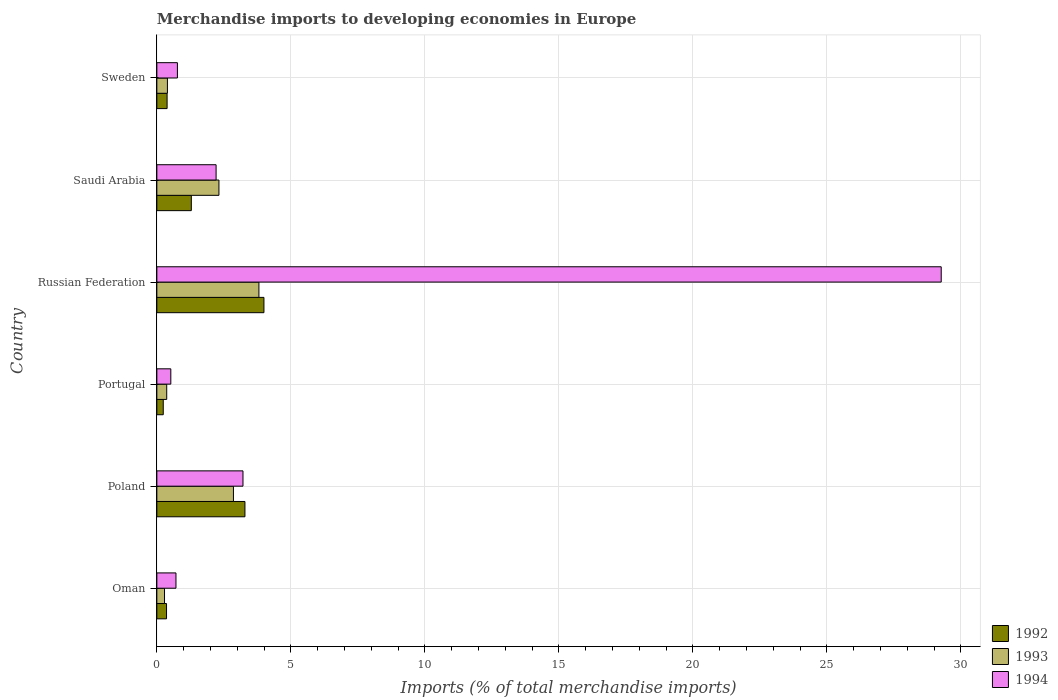How many different coloured bars are there?
Your response must be concise. 3. Are the number of bars per tick equal to the number of legend labels?
Provide a short and direct response. Yes. What is the label of the 2nd group of bars from the top?
Offer a terse response. Saudi Arabia. In how many cases, is the number of bars for a given country not equal to the number of legend labels?
Provide a short and direct response. 0. What is the percentage total merchandise imports in 1994 in Oman?
Offer a terse response. 0.71. Across all countries, what is the maximum percentage total merchandise imports in 1994?
Ensure brevity in your answer.  29.26. Across all countries, what is the minimum percentage total merchandise imports in 1992?
Provide a succinct answer. 0.24. In which country was the percentage total merchandise imports in 1992 maximum?
Your response must be concise. Russian Federation. What is the total percentage total merchandise imports in 1994 in the graph?
Your answer should be compact. 36.69. What is the difference between the percentage total merchandise imports in 1993 in Oman and that in Portugal?
Ensure brevity in your answer.  -0.08. What is the difference between the percentage total merchandise imports in 1993 in Saudi Arabia and the percentage total merchandise imports in 1994 in Sweden?
Your response must be concise. 1.55. What is the average percentage total merchandise imports in 1992 per country?
Give a very brief answer. 1.59. What is the difference between the percentage total merchandise imports in 1994 and percentage total merchandise imports in 1993 in Portugal?
Give a very brief answer. 0.15. What is the ratio of the percentage total merchandise imports in 1993 in Portugal to that in Saudi Arabia?
Offer a very short reply. 0.16. Is the percentage total merchandise imports in 1993 in Poland less than that in Portugal?
Make the answer very short. No. What is the difference between the highest and the second highest percentage total merchandise imports in 1994?
Ensure brevity in your answer.  26.05. What is the difference between the highest and the lowest percentage total merchandise imports in 1994?
Ensure brevity in your answer.  28.74. What does the 1st bar from the bottom in Oman represents?
Make the answer very short. 1992. Is it the case that in every country, the sum of the percentage total merchandise imports in 1992 and percentage total merchandise imports in 1994 is greater than the percentage total merchandise imports in 1993?
Ensure brevity in your answer.  Yes. Are all the bars in the graph horizontal?
Your answer should be very brief. Yes. How many countries are there in the graph?
Your response must be concise. 6. Does the graph contain any zero values?
Your response must be concise. No. Where does the legend appear in the graph?
Provide a short and direct response. Bottom right. How many legend labels are there?
Your answer should be very brief. 3. What is the title of the graph?
Provide a succinct answer. Merchandise imports to developing economies in Europe. Does "1960" appear as one of the legend labels in the graph?
Your response must be concise. No. What is the label or title of the X-axis?
Your answer should be compact. Imports (% of total merchandise imports). What is the label or title of the Y-axis?
Your answer should be very brief. Country. What is the Imports (% of total merchandise imports) in 1992 in Oman?
Ensure brevity in your answer.  0.36. What is the Imports (% of total merchandise imports) in 1993 in Oman?
Give a very brief answer. 0.29. What is the Imports (% of total merchandise imports) in 1994 in Oman?
Make the answer very short. 0.71. What is the Imports (% of total merchandise imports) of 1992 in Poland?
Offer a very short reply. 3.29. What is the Imports (% of total merchandise imports) of 1993 in Poland?
Provide a short and direct response. 2.86. What is the Imports (% of total merchandise imports) in 1994 in Poland?
Provide a short and direct response. 3.21. What is the Imports (% of total merchandise imports) in 1992 in Portugal?
Make the answer very short. 0.24. What is the Imports (% of total merchandise imports) of 1993 in Portugal?
Give a very brief answer. 0.37. What is the Imports (% of total merchandise imports) of 1994 in Portugal?
Offer a terse response. 0.52. What is the Imports (% of total merchandise imports) in 1992 in Russian Federation?
Your answer should be compact. 4. What is the Imports (% of total merchandise imports) in 1993 in Russian Federation?
Ensure brevity in your answer.  3.81. What is the Imports (% of total merchandise imports) of 1994 in Russian Federation?
Make the answer very short. 29.26. What is the Imports (% of total merchandise imports) in 1992 in Saudi Arabia?
Your response must be concise. 1.29. What is the Imports (% of total merchandise imports) of 1993 in Saudi Arabia?
Your answer should be very brief. 2.32. What is the Imports (% of total merchandise imports) of 1994 in Saudi Arabia?
Offer a very short reply. 2.21. What is the Imports (% of total merchandise imports) in 1992 in Sweden?
Offer a terse response. 0.38. What is the Imports (% of total merchandise imports) of 1993 in Sweden?
Give a very brief answer. 0.39. What is the Imports (% of total merchandise imports) of 1994 in Sweden?
Keep it short and to the point. 0.77. Across all countries, what is the maximum Imports (% of total merchandise imports) in 1992?
Offer a very short reply. 4. Across all countries, what is the maximum Imports (% of total merchandise imports) of 1993?
Ensure brevity in your answer.  3.81. Across all countries, what is the maximum Imports (% of total merchandise imports) of 1994?
Provide a short and direct response. 29.26. Across all countries, what is the minimum Imports (% of total merchandise imports) of 1992?
Provide a short and direct response. 0.24. Across all countries, what is the minimum Imports (% of total merchandise imports) of 1993?
Ensure brevity in your answer.  0.29. Across all countries, what is the minimum Imports (% of total merchandise imports) of 1994?
Provide a short and direct response. 0.52. What is the total Imports (% of total merchandise imports) in 1992 in the graph?
Ensure brevity in your answer.  9.55. What is the total Imports (% of total merchandise imports) in 1993 in the graph?
Provide a short and direct response. 10.03. What is the total Imports (% of total merchandise imports) of 1994 in the graph?
Ensure brevity in your answer.  36.69. What is the difference between the Imports (% of total merchandise imports) of 1992 in Oman and that in Poland?
Keep it short and to the point. -2.93. What is the difference between the Imports (% of total merchandise imports) in 1993 in Oman and that in Poland?
Offer a terse response. -2.57. What is the difference between the Imports (% of total merchandise imports) of 1992 in Oman and that in Portugal?
Your response must be concise. 0.12. What is the difference between the Imports (% of total merchandise imports) in 1993 in Oman and that in Portugal?
Keep it short and to the point. -0.08. What is the difference between the Imports (% of total merchandise imports) of 1994 in Oman and that in Portugal?
Your answer should be compact. 0.19. What is the difference between the Imports (% of total merchandise imports) of 1992 in Oman and that in Russian Federation?
Give a very brief answer. -3.63. What is the difference between the Imports (% of total merchandise imports) in 1993 in Oman and that in Russian Federation?
Give a very brief answer. -3.52. What is the difference between the Imports (% of total merchandise imports) of 1994 in Oman and that in Russian Federation?
Give a very brief answer. -28.55. What is the difference between the Imports (% of total merchandise imports) in 1992 in Oman and that in Saudi Arabia?
Ensure brevity in your answer.  -0.92. What is the difference between the Imports (% of total merchandise imports) in 1993 in Oman and that in Saudi Arabia?
Provide a succinct answer. -2.03. What is the difference between the Imports (% of total merchandise imports) in 1994 in Oman and that in Saudi Arabia?
Give a very brief answer. -1.5. What is the difference between the Imports (% of total merchandise imports) of 1992 in Oman and that in Sweden?
Offer a terse response. -0.02. What is the difference between the Imports (% of total merchandise imports) in 1993 in Oman and that in Sweden?
Offer a very short reply. -0.11. What is the difference between the Imports (% of total merchandise imports) in 1994 in Oman and that in Sweden?
Your answer should be compact. -0.05. What is the difference between the Imports (% of total merchandise imports) in 1992 in Poland and that in Portugal?
Make the answer very short. 3.05. What is the difference between the Imports (% of total merchandise imports) in 1993 in Poland and that in Portugal?
Give a very brief answer. 2.49. What is the difference between the Imports (% of total merchandise imports) in 1994 in Poland and that in Portugal?
Keep it short and to the point. 2.69. What is the difference between the Imports (% of total merchandise imports) in 1992 in Poland and that in Russian Federation?
Keep it short and to the point. -0.71. What is the difference between the Imports (% of total merchandise imports) of 1993 in Poland and that in Russian Federation?
Your answer should be very brief. -0.95. What is the difference between the Imports (% of total merchandise imports) of 1994 in Poland and that in Russian Federation?
Provide a succinct answer. -26.05. What is the difference between the Imports (% of total merchandise imports) of 1992 in Poland and that in Saudi Arabia?
Give a very brief answer. 2. What is the difference between the Imports (% of total merchandise imports) of 1993 in Poland and that in Saudi Arabia?
Your response must be concise. 0.54. What is the difference between the Imports (% of total merchandise imports) of 1992 in Poland and that in Sweden?
Provide a succinct answer. 2.9. What is the difference between the Imports (% of total merchandise imports) of 1993 in Poland and that in Sweden?
Ensure brevity in your answer.  2.46. What is the difference between the Imports (% of total merchandise imports) in 1994 in Poland and that in Sweden?
Provide a succinct answer. 2.45. What is the difference between the Imports (% of total merchandise imports) of 1992 in Portugal and that in Russian Federation?
Make the answer very short. -3.76. What is the difference between the Imports (% of total merchandise imports) in 1993 in Portugal and that in Russian Federation?
Your response must be concise. -3.44. What is the difference between the Imports (% of total merchandise imports) in 1994 in Portugal and that in Russian Federation?
Offer a terse response. -28.74. What is the difference between the Imports (% of total merchandise imports) in 1992 in Portugal and that in Saudi Arabia?
Ensure brevity in your answer.  -1.05. What is the difference between the Imports (% of total merchandise imports) of 1993 in Portugal and that in Saudi Arabia?
Offer a terse response. -1.95. What is the difference between the Imports (% of total merchandise imports) of 1994 in Portugal and that in Saudi Arabia?
Provide a succinct answer. -1.69. What is the difference between the Imports (% of total merchandise imports) in 1992 in Portugal and that in Sweden?
Your response must be concise. -0.14. What is the difference between the Imports (% of total merchandise imports) of 1993 in Portugal and that in Sweden?
Your answer should be compact. -0.03. What is the difference between the Imports (% of total merchandise imports) in 1994 in Portugal and that in Sweden?
Your answer should be compact. -0.25. What is the difference between the Imports (% of total merchandise imports) in 1992 in Russian Federation and that in Saudi Arabia?
Your answer should be very brief. 2.71. What is the difference between the Imports (% of total merchandise imports) of 1993 in Russian Federation and that in Saudi Arabia?
Offer a very short reply. 1.49. What is the difference between the Imports (% of total merchandise imports) of 1994 in Russian Federation and that in Saudi Arabia?
Offer a terse response. 27.05. What is the difference between the Imports (% of total merchandise imports) in 1992 in Russian Federation and that in Sweden?
Keep it short and to the point. 3.61. What is the difference between the Imports (% of total merchandise imports) of 1993 in Russian Federation and that in Sweden?
Your answer should be compact. 3.41. What is the difference between the Imports (% of total merchandise imports) of 1994 in Russian Federation and that in Sweden?
Give a very brief answer. 28.5. What is the difference between the Imports (% of total merchandise imports) in 1992 in Saudi Arabia and that in Sweden?
Your response must be concise. 0.9. What is the difference between the Imports (% of total merchandise imports) in 1993 in Saudi Arabia and that in Sweden?
Your answer should be compact. 1.92. What is the difference between the Imports (% of total merchandise imports) in 1994 in Saudi Arabia and that in Sweden?
Your answer should be very brief. 1.44. What is the difference between the Imports (% of total merchandise imports) in 1992 in Oman and the Imports (% of total merchandise imports) in 1993 in Poland?
Give a very brief answer. -2.5. What is the difference between the Imports (% of total merchandise imports) of 1992 in Oman and the Imports (% of total merchandise imports) of 1994 in Poland?
Offer a very short reply. -2.85. What is the difference between the Imports (% of total merchandise imports) of 1993 in Oman and the Imports (% of total merchandise imports) of 1994 in Poland?
Your answer should be compact. -2.93. What is the difference between the Imports (% of total merchandise imports) in 1992 in Oman and the Imports (% of total merchandise imports) in 1993 in Portugal?
Offer a very short reply. -0.01. What is the difference between the Imports (% of total merchandise imports) in 1992 in Oman and the Imports (% of total merchandise imports) in 1994 in Portugal?
Provide a succinct answer. -0.16. What is the difference between the Imports (% of total merchandise imports) of 1993 in Oman and the Imports (% of total merchandise imports) of 1994 in Portugal?
Your response must be concise. -0.23. What is the difference between the Imports (% of total merchandise imports) of 1992 in Oman and the Imports (% of total merchandise imports) of 1993 in Russian Federation?
Offer a very short reply. -3.45. What is the difference between the Imports (% of total merchandise imports) of 1992 in Oman and the Imports (% of total merchandise imports) of 1994 in Russian Federation?
Keep it short and to the point. -28.9. What is the difference between the Imports (% of total merchandise imports) in 1993 in Oman and the Imports (% of total merchandise imports) in 1994 in Russian Federation?
Offer a terse response. -28.98. What is the difference between the Imports (% of total merchandise imports) of 1992 in Oman and the Imports (% of total merchandise imports) of 1993 in Saudi Arabia?
Offer a very short reply. -1.96. What is the difference between the Imports (% of total merchandise imports) of 1992 in Oman and the Imports (% of total merchandise imports) of 1994 in Saudi Arabia?
Offer a terse response. -1.85. What is the difference between the Imports (% of total merchandise imports) in 1993 in Oman and the Imports (% of total merchandise imports) in 1994 in Saudi Arabia?
Your answer should be very brief. -1.92. What is the difference between the Imports (% of total merchandise imports) in 1992 in Oman and the Imports (% of total merchandise imports) in 1993 in Sweden?
Your answer should be compact. -0.03. What is the difference between the Imports (% of total merchandise imports) of 1992 in Oman and the Imports (% of total merchandise imports) of 1994 in Sweden?
Provide a succinct answer. -0.41. What is the difference between the Imports (% of total merchandise imports) in 1993 in Oman and the Imports (% of total merchandise imports) in 1994 in Sweden?
Give a very brief answer. -0.48. What is the difference between the Imports (% of total merchandise imports) of 1992 in Poland and the Imports (% of total merchandise imports) of 1993 in Portugal?
Provide a short and direct response. 2.92. What is the difference between the Imports (% of total merchandise imports) in 1992 in Poland and the Imports (% of total merchandise imports) in 1994 in Portugal?
Provide a succinct answer. 2.77. What is the difference between the Imports (% of total merchandise imports) in 1993 in Poland and the Imports (% of total merchandise imports) in 1994 in Portugal?
Offer a very short reply. 2.34. What is the difference between the Imports (% of total merchandise imports) of 1992 in Poland and the Imports (% of total merchandise imports) of 1993 in Russian Federation?
Your answer should be compact. -0.52. What is the difference between the Imports (% of total merchandise imports) in 1992 in Poland and the Imports (% of total merchandise imports) in 1994 in Russian Federation?
Keep it short and to the point. -25.98. What is the difference between the Imports (% of total merchandise imports) in 1993 in Poland and the Imports (% of total merchandise imports) in 1994 in Russian Federation?
Ensure brevity in your answer.  -26.41. What is the difference between the Imports (% of total merchandise imports) of 1992 in Poland and the Imports (% of total merchandise imports) of 1993 in Saudi Arabia?
Ensure brevity in your answer.  0.97. What is the difference between the Imports (% of total merchandise imports) in 1992 in Poland and the Imports (% of total merchandise imports) in 1994 in Saudi Arabia?
Your answer should be very brief. 1.08. What is the difference between the Imports (% of total merchandise imports) in 1993 in Poland and the Imports (% of total merchandise imports) in 1994 in Saudi Arabia?
Provide a succinct answer. 0.65. What is the difference between the Imports (% of total merchandise imports) of 1992 in Poland and the Imports (% of total merchandise imports) of 1993 in Sweden?
Give a very brief answer. 2.89. What is the difference between the Imports (% of total merchandise imports) in 1992 in Poland and the Imports (% of total merchandise imports) in 1994 in Sweden?
Provide a succinct answer. 2.52. What is the difference between the Imports (% of total merchandise imports) of 1993 in Poland and the Imports (% of total merchandise imports) of 1994 in Sweden?
Make the answer very short. 2.09. What is the difference between the Imports (% of total merchandise imports) in 1992 in Portugal and the Imports (% of total merchandise imports) in 1993 in Russian Federation?
Provide a short and direct response. -3.57. What is the difference between the Imports (% of total merchandise imports) in 1992 in Portugal and the Imports (% of total merchandise imports) in 1994 in Russian Federation?
Your response must be concise. -29.03. What is the difference between the Imports (% of total merchandise imports) of 1993 in Portugal and the Imports (% of total merchandise imports) of 1994 in Russian Federation?
Keep it short and to the point. -28.9. What is the difference between the Imports (% of total merchandise imports) in 1992 in Portugal and the Imports (% of total merchandise imports) in 1993 in Saudi Arabia?
Your response must be concise. -2.08. What is the difference between the Imports (% of total merchandise imports) of 1992 in Portugal and the Imports (% of total merchandise imports) of 1994 in Saudi Arabia?
Give a very brief answer. -1.97. What is the difference between the Imports (% of total merchandise imports) in 1993 in Portugal and the Imports (% of total merchandise imports) in 1994 in Saudi Arabia?
Your answer should be compact. -1.84. What is the difference between the Imports (% of total merchandise imports) of 1992 in Portugal and the Imports (% of total merchandise imports) of 1993 in Sweden?
Make the answer very short. -0.16. What is the difference between the Imports (% of total merchandise imports) of 1992 in Portugal and the Imports (% of total merchandise imports) of 1994 in Sweden?
Your response must be concise. -0.53. What is the difference between the Imports (% of total merchandise imports) of 1993 in Portugal and the Imports (% of total merchandise imports) of 1994 in Sweden?
Offer a terse response. -0.4. What is the difference between the Imports (% of total merchandise imports) in 1992 in Russian Federation and the Imports (% of total merchandise imports) in 1993 in Saudi Arabia?
Make the answer very short. 1.68. What is the difference between the Imports (% of total merchandise imports) of 1992 in Russian Federation and the Imports (% of total merchandise imports) of 1994 in Saudi Arabia?
Provide a succinct answer. 1.79. What is the difference between the Imports (% of total merchandise imports) of 1993 in Russian Federation and the Imports (% of total merchandise imports) of 1994 in Saudi Arabia?
Your response must be concise. 1.6. What is the difference between the Imports (% of total merchandise imports) in 1992 in Russian Federation and the Imports (% of total merchandise imports) in 1993 in Sweden?
Give a very brief answer. 3.6. What is the difference between the Imports (% of total merchandise imports) in 1992 in Russian Federation and the Imports (% of total merchandise imports) in 1994 in Sweden?
Offer a very short reply. 3.23. What is the difference between the Imports (% of total merchandise imports) of 1993 in Russian Federation and the Imports (% of total merchandise imports) of 1994 in Sweden?
Provide a short and direct response. 3.04. What is the difference between the Imports (% of total merchandise imports) of 1992 in Saudi Arabia and the Imports (% of total merchandise imports) of 1993 in Sweden?
Keep it short and to the point. 0.89. What is the difference between the Imports (% of total merchandise imports) of 1992 in Saudi Arabia and the Imports (% of total merchandise imports) of 1994 in Sweden?
Ensure brevity in your answer.  0.52. What is the difference between the Imports (% of total merchandise imports) of 1993 in Saudi Arabia and the Imports (% of total merchandise imports) of 1994 in Sweden?
Give a very brief answer. 1.55. What is the average Imports (% of total merchandise imports) in 1992 per country?
Your answer should be very brief. 1.59. What is the average Imports (% of total merchandise imports) of 1993 per country?
Give a very brief answer. 1.67. What is the average Imports (% of total merchandise imports) in 1994 per country?
Make the answer very short. 6.12. What is the difference between the Imports (% of total merchandise imports) of 1992 and Imports (% of total merchandise imports) of 1993 in Oman?
Ensure brevity in your answer.  0.08. What is the difference between the Imports (% of total merchandise imports) in 1992 and Imports (% of total merchandise imports) in 1994 in Oman?
Offer a terse response. -0.35. What is the difference between the Imports (% of total merchandise imports) of 1993 and Imports (% of total merchandise imports) of 1994 in Oman?
Keep it short and to the point. -0.43. What is the difference between the Imports (% of total merchandise imports) of 1992 and Imports (% of total merchandise imports) of 1993 in Poland?
Provide a short and direct response. 0.43. What is the difference between the Imports (% of total merchandise imports) of 1992 and Imports (% of total merchandise imports) of 1994 in Poland?
Offer a very short reply. 0.07. What is the difference between the Imports (% of total merchandise imports) of 1993 and Imports (% of total merchandise imports) of 1994 in Poland?
Provide a succinct answer. -0.36. What is the difference between the Imports (% of total merchandise imports) of 1992 and Imports (% of total merchandise imports) of 1993 in Portugal?
Keep it short and to the point. -0.13. What is the difference between the Imports (% of total merchandise imports) in 1992 and Imports (% of total merchandise imports) in 1994 in Portugal?
Ensure brevity in your answer.  -0.28. What is the difference between the Imports (% of total merchandise imports) of 1993 and Imports (% of total merchandise imports) of 1994 in Portugal?
Offer a very short reply. -0.15. What is the difference between the Imports (% of total merchandise imports) in 1992 and Imports (% of total merchandise imports) in 1993 in Russian Federation?
Your response must be concise. 0.19. What is the difference between the Imports (% of total merchandise imports) in 1992 and Imports (% of total merchandise imports) in 1994 in Russian Federation?
Keep it short and to the point. -25.27. What is the difference between the Imports (% of total merchandise imports) of 1993 and Imports (% of total merchandise imports) of 1994 in Russian Federation?
Offer a very short reply. -25.46. What is the difference between the Imports (% of total merchandise imports) in 1992 and Imports (% of total merchandise imports) in 1993 in Saudi Arabia?
Offer a terse response. -1.03. What is the difference between the Imports (% of total merchandise imports) in 1992 and Imports (% of total merchandise imports) in 1994 in Saudi Arabia?
Make the answer very short. -0.92. What is the difference between the Imports (% of total merchandise imports) in 1993 and Imports (% of total merchandise imports) in 1994 in Saudi Arabia?
Your answer should be very brief. 0.11. What is the difference between the Imports (% of total merchandise imports) of 1992 and Imports (% of total merchandise imports) of 1993 in Sweden?
Offer a terse response. -0.01. What is the difference between the Imports (% of total merchandise imports) of 1992 and Imports (% of total merchandise imports) of 1994 in Sweden?
Ensure brevity in your answer.  -0.39. What is the difference between the Imports (% of total merchandise imports) of 1993 and Imports (% of total merchandise imports) of 1994 in Sweden?
Offer a terse response. -0.37. What is the ratio of the Imports (% of total merchandise imports) in 1992 in Oman to that in Poland?
Provide a succinct answer. 0.11. What is the ratio of the Imports (% of total merchandise imports) in 1993 in Oman to that in Poland?
Your response must be concise. 0.1. What is the ratio of the Imports (% of total merchandise imports) in 1994 in Oman to that in Poland?
Make the answer very short. 0.22. What is the ratio of the Imports (% of total merchandise imports) of 1992 in Oman to that in Portugal?
Offer a terse response. 1.51. What is the ratio of the Imports (% of total merchandise imports) of 1993 in Oman to that in Portugal?
Keep it short and to the point. 0.78. What is the ratio of the Imports (% of total merchandise imports) in 1994 in Oman to that in Portugal?
Ensure brevity in your answer.  1.37. What is the ratio of the Imports (% of total merchandise imports) in 1992 in Oman to that in Russian Federation?
Provide a succinct answer. 0.09. What is the ratio of the Imports (% of total merchandise imports) in 1993 in Oman to that in Russian Federation?
Make the answer very short. 0.08. What is the ratio of the Imports (% of total merchandise imports) in 1994 in Oman to that in Russian Federation?
Give a very brief answer. 0.02. What is the ratio of the Imports (% of total merchandise imports) in 1992 in Oman to that in Saudi Arabia?
Offer a terse response. 0.28. What is the ratio of the Imports (% of total merchandise imports) in 1993 in Oman to that in Saudi Arabia?
Your answer should be compact. 0.12. What is the ratio of the Imports (% of total merchandise imports) in 1994 in Oman to that in Saudi Arabia?
Your answer should be compact. 0.32. What is the ratio of the Imports (% of total merchandise imports) of 1992 in Oman to that in Sweden?
Offer a very short reply. 0.94. What is the ratio of the Imports (% of total merchandise imports) in 1993 in Oman to that in Sweden?
Make the answer very short. 0.73. What is the ratio of the Imports (% of total merchandise imports) in 1994 in Oman to that in Sweden?
Keep it short and to the point. 0.93. What is the ratio of the Imports (% of total merchandise imports) of 1992 in Poland to that in Portugal?
Ensure brevity in your answer.  13.77. What is the ratio of the Imports (% of total merchandise imports) in 1993 in Poland to that in Portugal?
Your response must be concise. 7.76. What is the ratio of the Imports (% of total merchandise imports) of 1994 in Poland to that in Portugal?
Your answer should be compact. 6.17. What is the ratio of the Imports (% of total merchandise imports) of 1992 in Poland to that in Russian Federation?
Ensure brevity in your answer.  0.82. What is the ratio of the Imports (% of total merchandise imports) of 1993 in Poland to that in Russian Federation?
Offer a terse response. 0.75. What is the ratio of the Imports (% of total merchandise imports) in 1994 in Poland to that in Russian Federation?
Offer a very short reply. 0.11. What is the ratio of the Imports (% of total merchandise imports) in 1992 in Poland to that in Saudi Arabia?
Ensure brevity in your answer.  2.56. What is the ratio of the Imports (% of total merchandise imports) in 1993 in Poland to that in Saudi Arabia?
Your response must be concise. 1.23. What is the ratio of the Imports (% of total merchandise imports) in 1994 in Poland to that in Saudi Arabia?
Keep it short and to the point. 1.45. What is the ratio of the Imports (% of total merchandise imports) in 1992 in Poland to that in Sweden?
Keep it short and to the point. 8.59. What is the ratio of the Imports (% of total merchandise imports) in 1993 in Poland to that in Sweden?
Offer a very short reply. 7.25. What is the ratio of the Imports (% of total merchandise imports) in 1994 in Poland to that in Sweden?
Provide a succinct answer. 4.19. What is the ratio of the Imports (% of total merchandise imports) in 1992 in Portugal to that in Russian Federation?
Keep it short and to the point. 0.06. What is the ratio of the Imports (% of total merchandise imports) in 1993 in Portugal to that in Russian Federation?
Give a very brief answer. 0.1. What is the ratio of the Imports (% of total merchandise imports) in 1994 in Portugal to that in Russian Federation?
Offer a terse response. 0.02. What is the ratio of the Imports (% of total merchandise imports) in 1992 in Portugal to that in Saudi Arabia?
Your answer should be compact. 0.19. What is the ratio of the Imports (% of total merchandise imports) in 1993 in Portugal to that in Saudi Arabia?
Give a very brief answer. 0.16. What is the ratio of the Imports (% of total merchandise imports) of 1994 in Portugal to that in Saudi Arabia?
Your answer should be very brief. 0.24. What is the ratio of the Imports (% of total merchandise imports) of 1992 in Portugal to that in Sweden?
Provide a succinct answer. 0.62. What is the ratio of the Imports (% of total merchandise imports) of 1993 in Portugal to that in Sweden?
Give a very brief answer. 0.93. What is the ratio of the Imports (% of total merchandise imports) in 1994 in Portugal to that in Sweden?
Your answer should be compact. 0.68. What is the ratio of the Imports (% of total merchandise imports) in 1992 in Russian Federation to that in Saudi Arabia?
Give a very brief answer. 3.11. What is the ratio of the Imports (% of total merchandise imports) of 1993 in Russian Federation to that in Saudi Arabia?
Offer a terse response. 1.64. What is the ratio of the Imports (% of total merchandise imports) in 1994 in Russian Federation to that in Saudi Arabia?
Give a very brief answer. 13.24. What is the ratio of the Imports (% of total merchandise imports) of 1992 in Russian Federation to that in Sweden?
Offer a very short reply. 10.44. What is the ratio of the Imports (% of total merchandise imports) in 1993 in Russian Federation to that in Sweden?
Make the answer very short. 9.66. What is the ratio of the Imports (% of total merchandise imports) of 1994 in Russian Federation to that in Sweden?
Make the answer very short. 38.12. What is the ratio of the Imports (% of total merchandise imports) of 1992 in Saudi Arabia to that in Sweden?
Your answer should be very brief. 3.36. What is the ratio of the Imports (% of total merchandise imports) of 1993 in Saudi Arabia to that in Sweden?
Your answer should be very brief. 5.87. What is the ratio of the Imports (% of total merchandise imports) in 1994 in Saudi Arabia to that in Sweden?
Offer a terse response. 2.88. What is the difference between the highest and the second highest Imports (% of total merchandise imports) in 1992?
Provide a succinct answer. 0.71. What is the difference between the highest and the second highest Imports (% of total merchandise imports) in 1993?
Your answer should be compact. 0.95. What is the difference between the highest and the second highest Imports (% of total merchandise imports) in 1994?
Your response must be concise. 26.05. What is the difference between the highest and the lowest Imports (% of total merchandise imports) of 1992?
Provide a succinct answer. 3.76. What is the difference between the highest and the lowest Imports (% of total merchandise imports) of 1993?
Make the answer very short. 3.52. What is the difference between the highest and the lowest Imports (% of total merchandise imports) of 1994?
Make the answer very short. 28.74. 